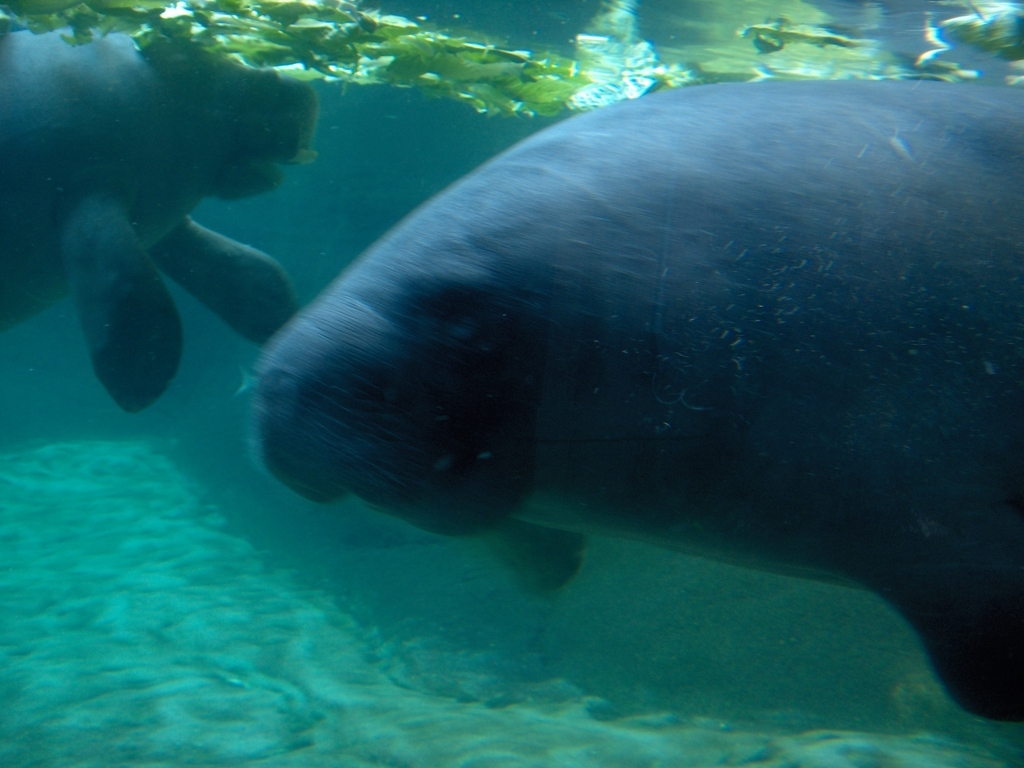What are the animals we see here? The animals in the image appear to be manatees, aquatic mammals known for their large, rounded bodies and paddle-like flippers. 